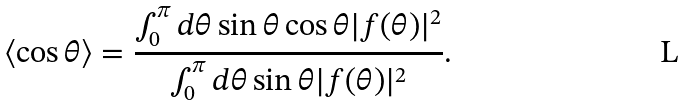Convert formula to latex. <formula><loc_0><loc_0><loc_500><loc_500>\langle \cos \theta \rangle = \frac { \int _ { 0 } ^ { \pi } d \theta \sin \theta \cos \theta | f ( \theta ) | ^ { 2 } } { \int _ { 0 } ^ { \pi } d \theta \sin \theta | f ( \theta ) | ^ { 2 } } .</formula> 